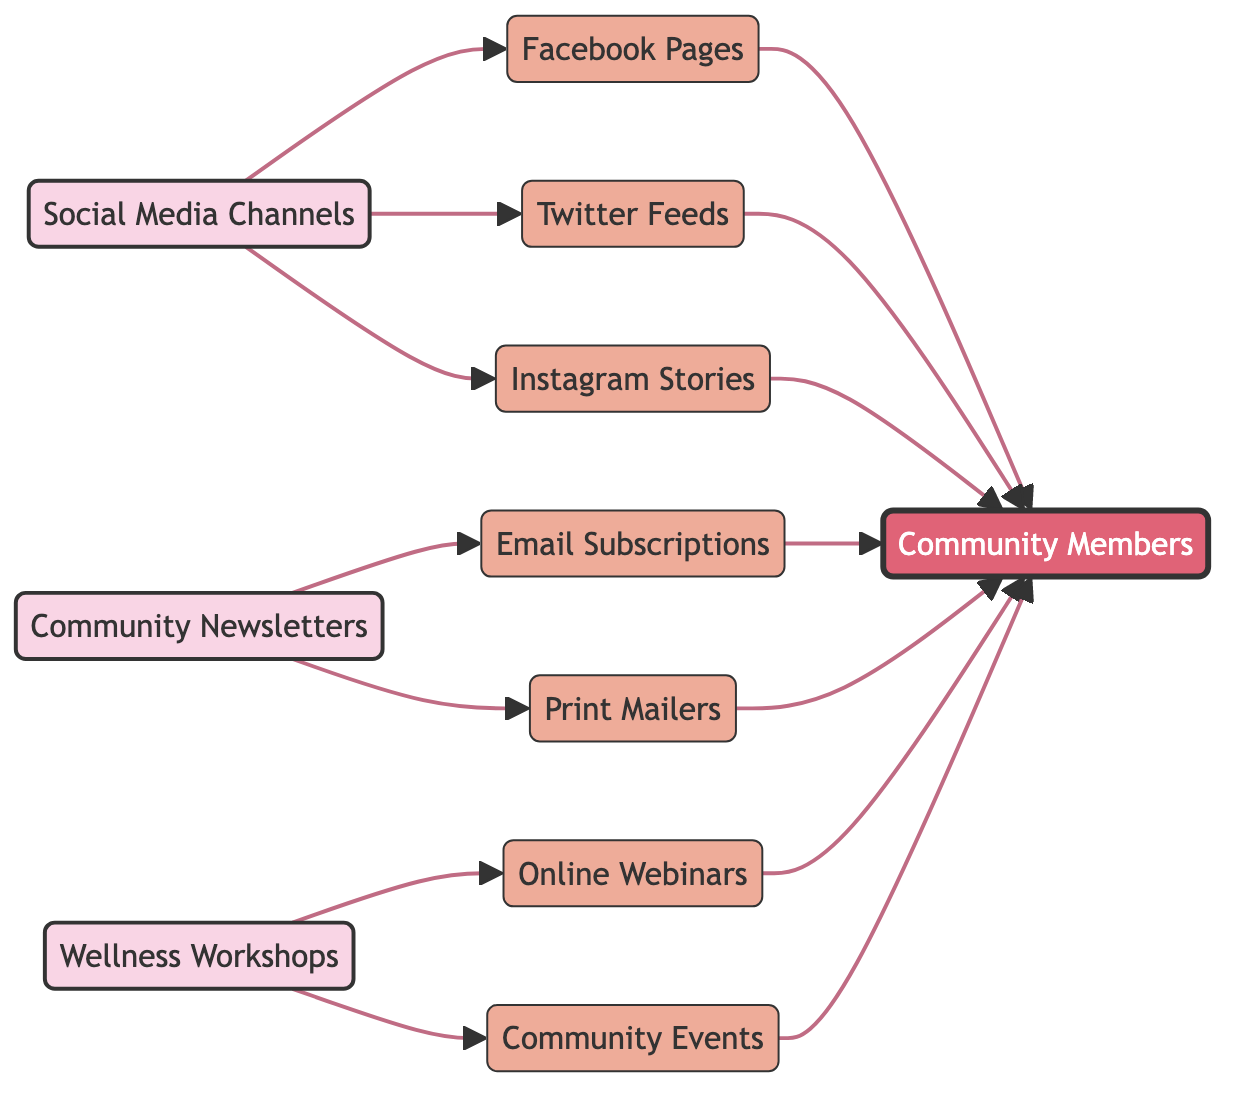What are the sources in the diagram? The sources in the diagram are identified as nodes with the type "source." Upon reviewing the diagram, the sources listed are Social Media Channels, Community Newsletters, and Wellness Workshops.
Answer: Social Media Channels, Community Newsletters, Wellness Workshops How many channel nodes are present? To find the number of channel nodes, we identify those nodes with the type "channel." The channel nodes are Facebook Pages, Twitter Feeds, Instagram Stories, Email Subscriptions, Print Mailers, Online Webinars, and Community Events, making a total of seven channel nodes.
Answer: 7 Which source connects to Print Mailers? To determine which source connects to Print Mailers, we trace the edges leading to this node. The only source that connects directly to Print Mailers is Community Newsletters.
Answer: Community Newsletters How many edges connect to Community Members? To find the edges connecting to Community Members, we look at all the nodes that lead to it. Each channel (Facebook, Twitter, Instagram, Email Subscriptions, Print Mailers, Online Webinars, Community Events) has an edge pointing to Community Members, resulting in a total of seven edges.
Answer: 7 What is the relationship between Wellness Workshops and Online Webinars? To understand the relationship between Wellness Workshops and Online Webinars, we check the edges connected to them. There is a directed edge that shows that Wellness Workshops leads to Online Webinars, indicating that information flows from Wellness Workshops to Online Webinars.
Answer: Direct connection Which channel has the least connections to Community Members in the diagram? Reviewing all the channels' connections to Community Members, we find that each channel (Facebook, Twitter, Instagram, Email Subscriptions, Print Mailers, Online Webinars, Community Events) has a direct edge leading to Community Members. Since there are no differentiations, all channels have an equal number of connections (one each).
Answer: All channels have equal connections How many sources in total are in the diagram? To find the total number of sources in the diagram, we count the nodes of type "source." There are three sources: Social Media Channels, Community Newsletters, and Wellness Workshops, resulting in a total of three sources.
Answer: 3 Which social media channel connects to the most community members? A direct examination of the diagram reveals that all social media channels (Facebook, Twitter, Instagram) have edges pointing to Community Members. Hence, they all contribute equally to connecting with Community Members, without any single channel being more prominent.
Answer: All equal What is the role of Community Newsletters in this diagram? The role of Community Newsletters in this diagram is to act as a source that distributes information through channels (Email Subscriptions and Print Mailers), which eventually connect to the Community Members.
Answer: Source for distribution 